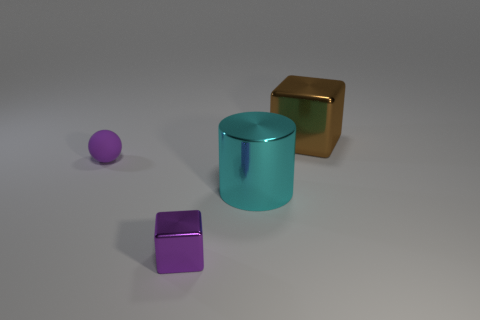Is the material of the tiny block the same as the big cylinder?
Give a very brief answer. Yes. There is a big shiny cube; what number of shiny things are in front of it?
Provide a short and direct response. 2. The other thing that is the same shape as the small purple metallic object is what size?
Offer a very short reply. Large. How many purple things are matte cubes or matte things?
Your response must be concise. 1. There is a block in front of the big metallic block; how many metal cubes are on the left side of it?
Your answer should be very brief. 0. What number of other things are the same shape as the brown shiny object?
Give a very brief answer. 1. There is a tiny object that is the same color as the small block; what material is it?
Give a very brief answer. Rubber. What number of cylinders have the same color as the small block?
Keep it short and to the point. 0. What is the color of the big thing that is the same material as the large cylinder?
Make the answer very short. Brown. Are there any purple rubber objects that have the same size as the purple matte sphere?
Offer a terse response. No. 